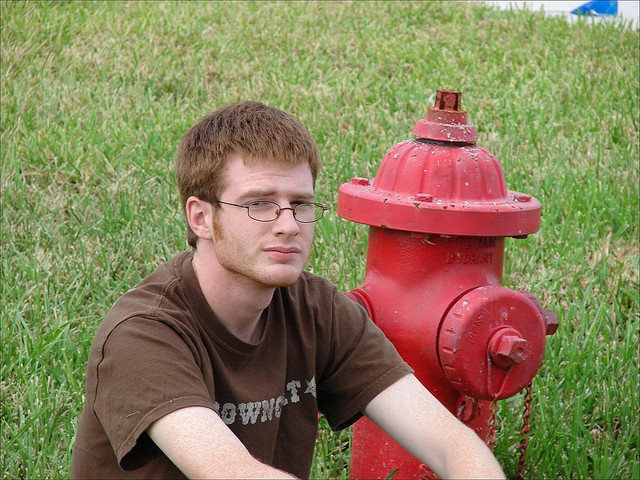Describe the objects in this image and their specific colors. I can see people in gray, black, and maroon tones and fire hydrant in gray, brown, salmon, and maroon tones in this image. 